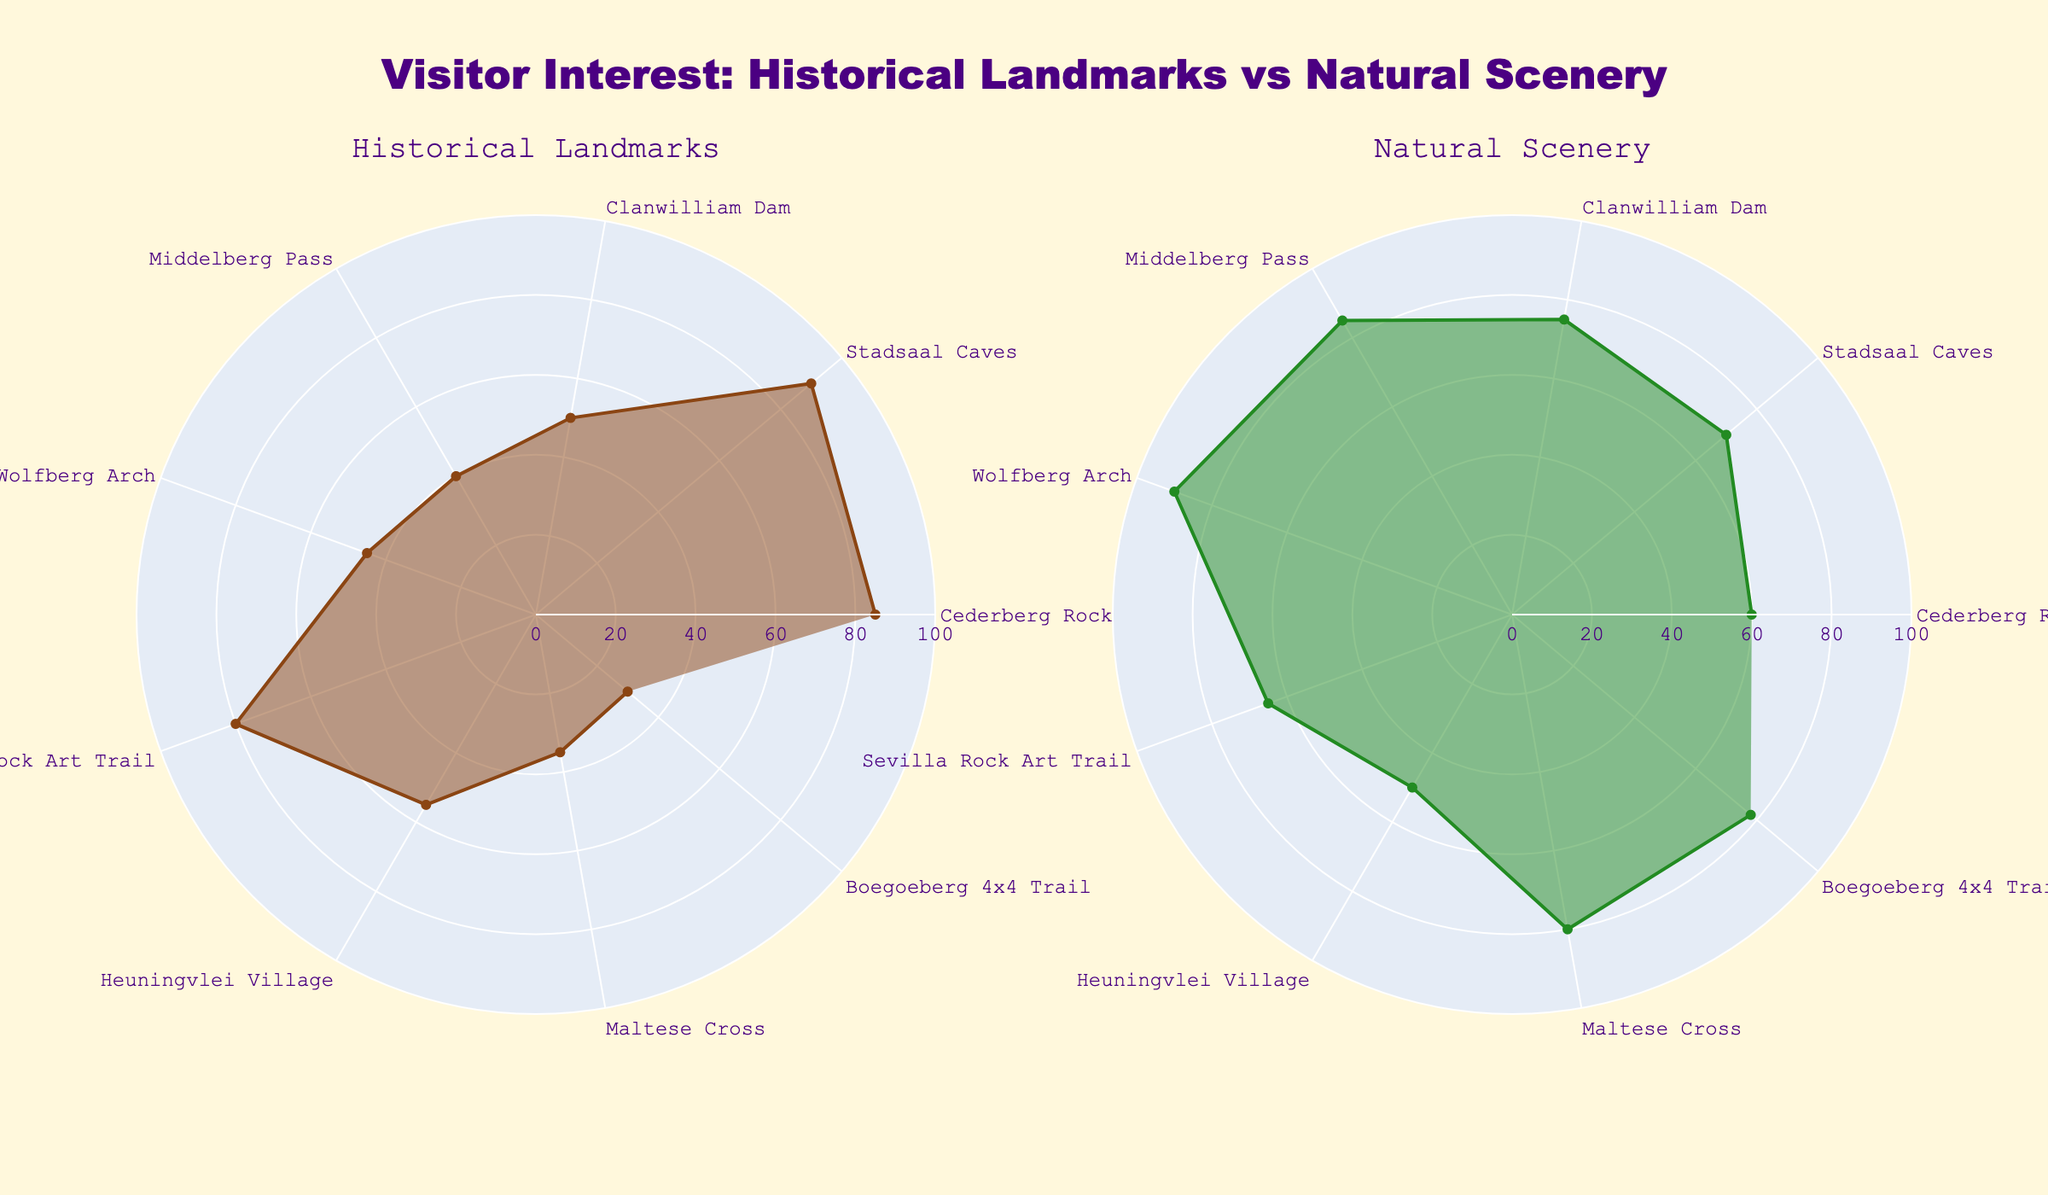What is the title of the figure? The title is located at the top center of the figure and reads "Visitor Interest: Historical Landmarks vs Natural Scenery".
Answer: Visitor Interest: Historical Landmarks vs Natural Scenery What colors are used for the different radar charts? The radar chart for Historical Landmarks uses a brown line and a semi-transparent brown fill, while the chart for Natural Scenery uses a green line and a semi-transparent green fill.
Answer: Brown and Green Which landmark has the highest visitor interest in historical landmarks? To find the landmark with the highest interest in historical landmarks, look for the longest radial line in the Historical Landmarks subplot. The Stadsaal Caves have the highest interest with a value of 90.
Answer: Stadsaal Caves Which landmark has the highest visitor interest in natural scenery? To determine the landmark with the highest interest in natural scenery, check the length of the radial lines in the Natural Scenery subplot. The Wolfberg Arch has the highest interest with a value of 90.
Answer: Wolfberg Arch How many landmarks have a higher interest in natural scenery compared to historical landmarks? For each landmark, compare the values of visitor interest in historical landmarks and natural scenery. The landmarks with higher interest in natural scenery are Clanwilliam Dam, Middelberg Pass, Wolfberg Arch, Maltese Cross, and Boegoeberg 4x4 Trail, making a total of 5 landmarks.
Answer: 5 What is the average visitor interest in historical landmarks among all landmarks? Add up the visitor interest values for historical landmarks (85 + 90 + 50 + 40 + 45 + 80 + 55 + 35 + 30) which is 510, then divide by the number of landmarks (9) to get the average.
Answer: 56.67 Compare the visitor interest in the Stadsaal Caves for both historical landmarks and natural scenery. Which one is higher and by how much? The interest in the Stadsaal Caves is 90 for historical landmarks and 70 for natural scenery. Subtract natural scenery interest from historical landmarks interest (90 - 70), so the interest in historical landmarks is higher by 20 points.
Answer: Historical landmarks, by 20 points Which landmark has the largest discrepancy between visitor interest in historical landmarks and natural scenery? For each landmark, calculate the absolute difference between interest in historical landmarks and natural scenery. The Middelberg Pass has the largest discrepancy with a difference of 45 (85 - 40).
Answer: Middelberg Pass What is the range of visitor interest values for natural scenery? The range is calculated by subtracting the minimum value from the maximum value in the Natural Scenery subplot. The maximum value is 90 (Wolfberg Arch) and the minimum is 50 (Heuningvlei Village), so the range is 90 - 50.
Answer: 40 Which two landmarks have similar visitor interest in historical landmarks but different interest in natural scenery? Compare the values in the Historical Landmarks subplot to find similar numbers, then check their values in the Natural Scenery subplot. Both Heuningvlei Village (55) and Clanwilliam Dam (50) have close interest in historical landmarks, but their natural scenery interest is quite different at 50 and 75, respectively.
Answer: Heuningvlei Village and Clanwilliam Dam 